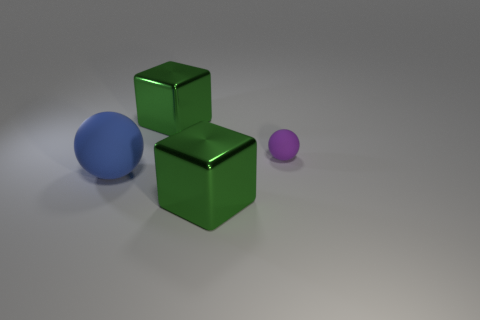Add 4 large matte balls. How many objects exist? 8 Subtract all small brown rubber cubes. Subtract all spheres. How many objects are left? 2 Add 4 big blue spheres. How many big blue spheres are left? 5 Add 4 large matte balls. How many large matte balls exist? 5 Subtract 0 brown cylinders. How many objects are left? 4 